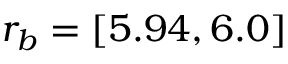Convert formula to latex. <formula><loc_0><loc_0><loc_500><loc_500>r _ { b } = [ 5 . 9 4 , 6 . 0 ]</formula> 